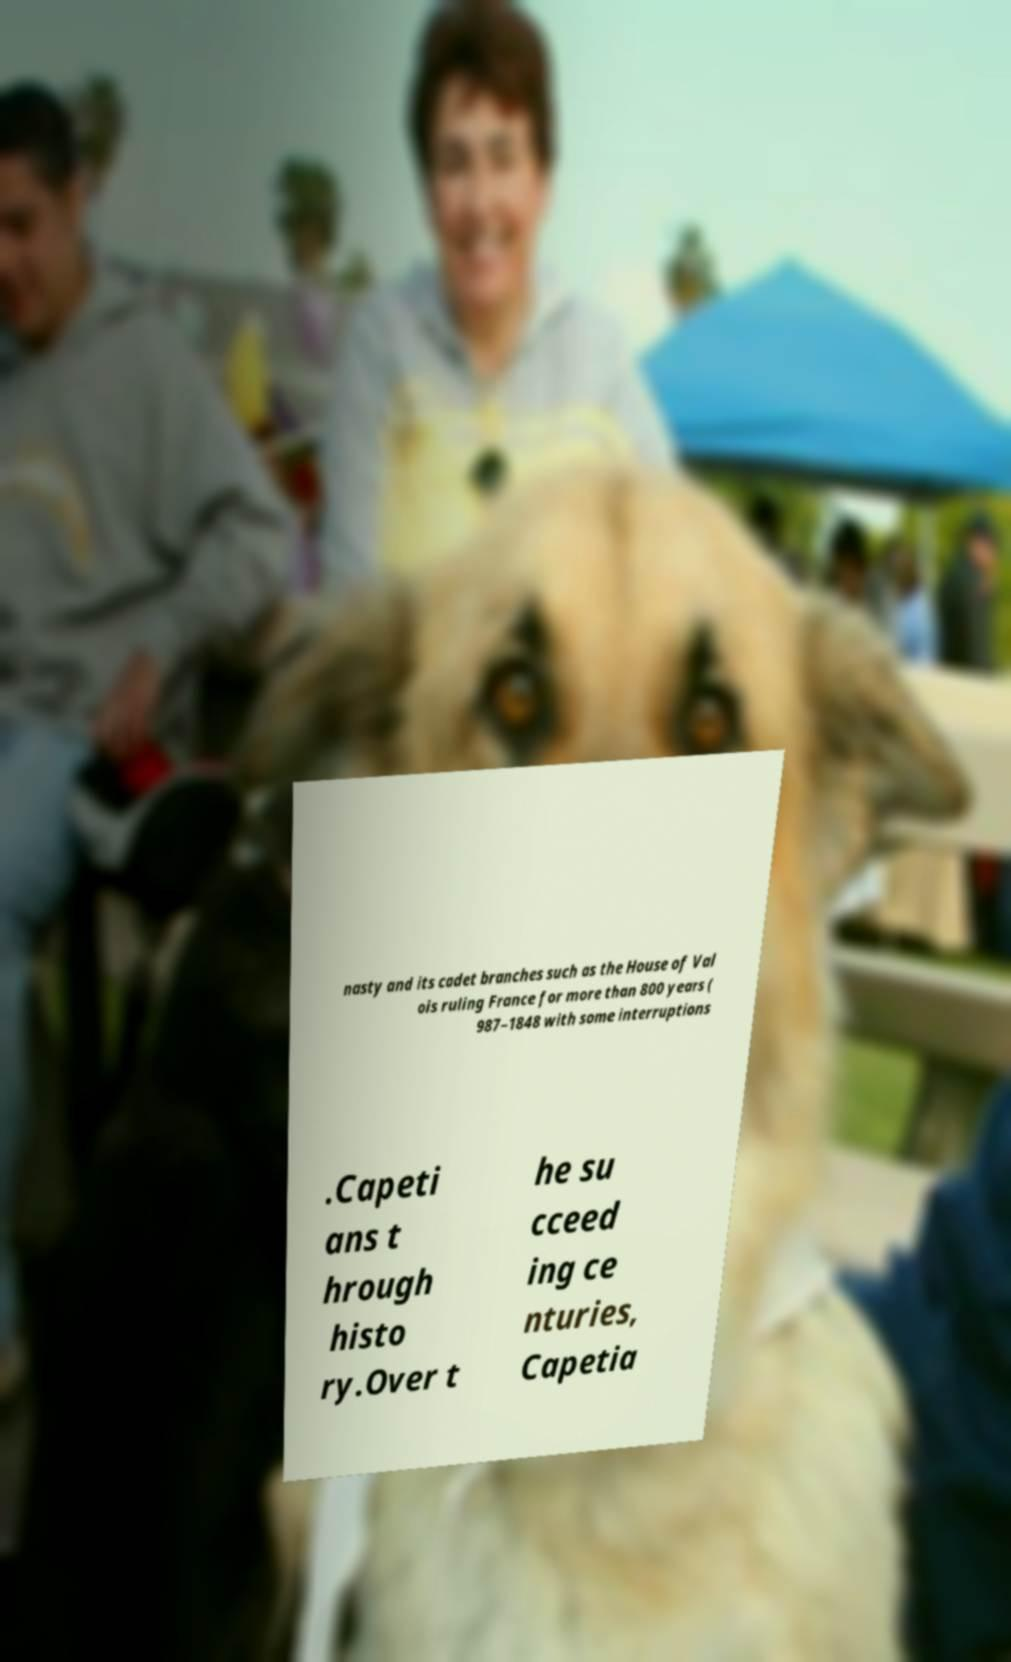What messages or text are displayed in this image? I need them in a readable, typed format. nasty and its cadet branches such as the House of Val ois ruling France for more than 800 years ( 987–1848 with some interruptions .Capeti ans t hrough histo ry.Over t he su cceed ing ce nturies, Capetia 